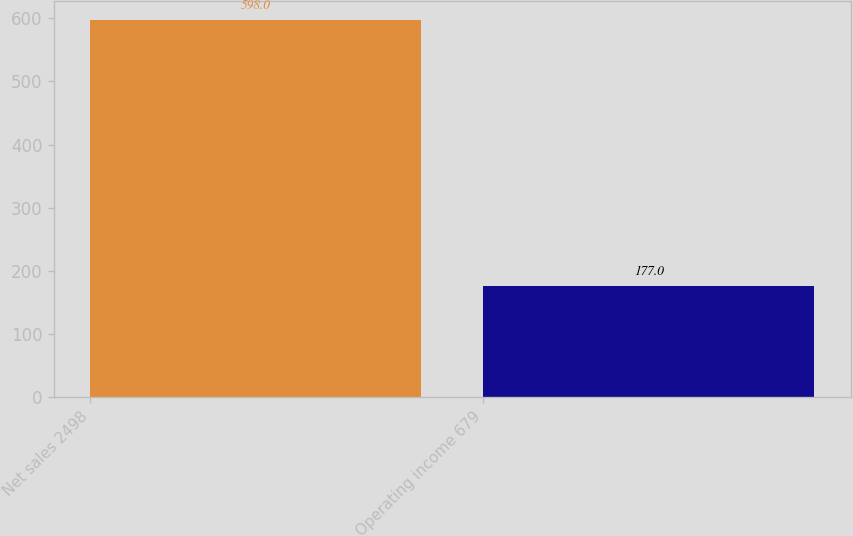Convert chart. <chart><loc_0><loc_0><loc_500><loc_500><bar_chart><fcel>Net sales 2498<fcel>Operating income 679<nl><fcel>598<fcel>177<nl></chart> 